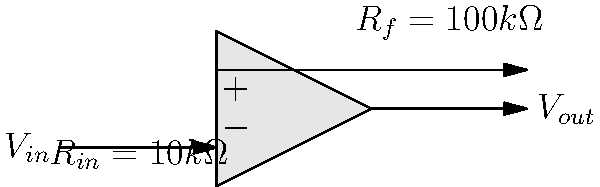As a restaurant owner looking to enhance your online presence with mouth-watering food images, you decide to explore photography equipment. You come across an operational amplifier circuit used in camera sensors. Given the circuit shown, with $R_f = 100k\Omega$ and $R_{in} = 10k\Omega$, what is the gain of this inverting amplifier configuration? Let's approach this step-by-step:

1) In an inverting amplifier configuration, the gain is given by the formula:

   $$ Gain = -\frac{R_f}{R_{in}} $$

   The negative sign indicates that the output is inverted compared to the input.

2) We are given:
   $R_f = 100k\Omega$
   $R_{in} = 10k\Omega$

3) Substituting these values into the formula:

   $$ Gain = -\frac{100k\Omega}{10k\Omega} $$

4) Simplifying:

   $$ Gain = -10 $$

This means that the output voltage will be 10 times the input voltage, but with the opposite polarity. In the context of camera sensors, this amplification could help in capturing details in low-light conditions, potentially resulting in clearer, more vibrant food images for your restaurant's online presence.
Answer: $-10$ 